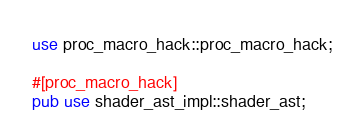<code> <loc_0><loc_0><loc_500><loc_500><_Rust_>use proc_macro_hack::proc_macro_hack;

#[proc_macro_hack]
pub use shader_ast_impl::shader_ast;</code> 